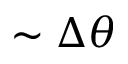<formula> <loc_0><loc_0><loc_500><loc_500>\sim \Delta \theta</formula> 